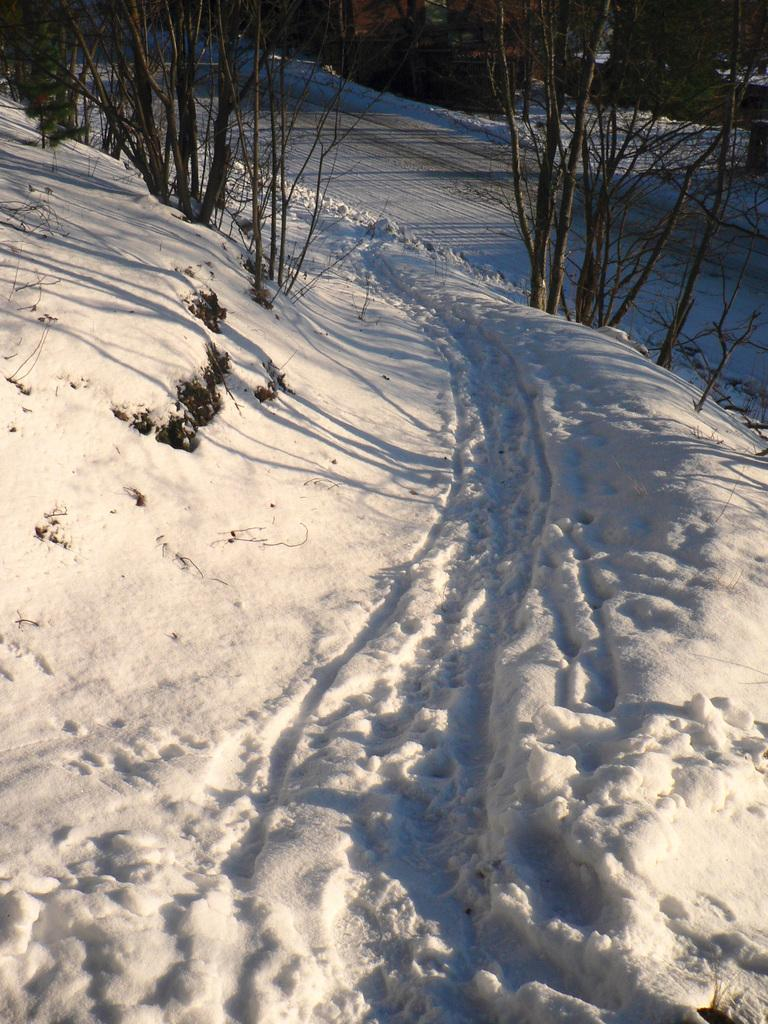What is the condition of the ground in the image? The ground is covered with snow. What type of vegetation can be seen in the image? There are plants and trees visible in the image. What is the man-made feature in the image? There is a road in the image. What is the mass of the snow in the image? The mass of the snow cannot be determined from the image alone, as it only provides a visual representation of the snow's presence. 